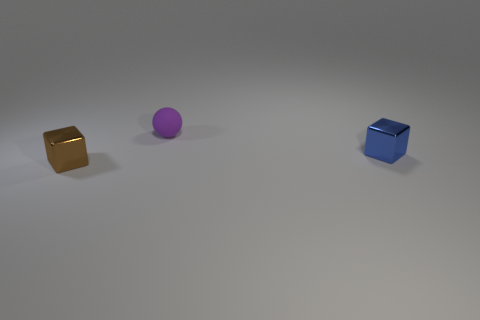Is there a large blue cylinder that has the same material as the tiny blue block?
Your answer should be compact. No. The matte ball has what color?
Give a very brief answer. Purple. Is the shape of the object that is to the right of the ball the same as  the brown object?
Offer a very short reply. Yes. There is a thing that is in front of the tiny metallic block that is to the right of the block that is on the left side of the purple matte thing; what is its shape?
Give a very brief answer. Cube. What material is the small cube that is on the left side of the tiny sphere?
Your answer should be very brief. Metal. What color is the ball that is the same size as the blue block?
Offer a terse response. Purple. How many other objects are the same shape as the tiny purple rubber thing?
Offer a very short reply. 0. Do the purple object and the blue thing have the same size?
Ensure brevity in your answer.  Yes. Are there more tiny cubes that are to the left of the small purple matte thing than blue things that are behind the tiny blue thing?
Provide a short and direct response. Yes. How many other things are there of the same size as the purple thing?
Your answer should be very brief. 2. 